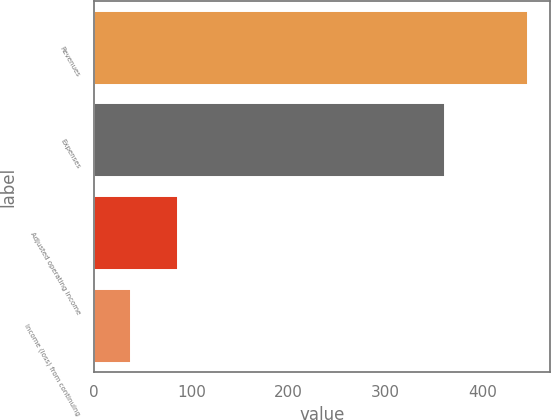<chart> <loc_0><loc_0><loc_500><loc_500><bar_chart><fcel>Revenues<fcel>Expenses<fcel>Adjusted operating income<fcel>Income (loss) from continuing<nl><fcel>447<fcel>361<fcel>86<fcel>38<nl></chart> 